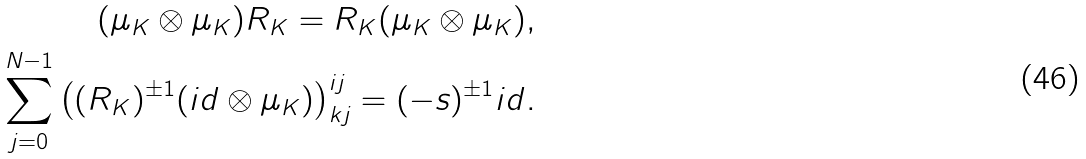<formula> <loc_0><loc_0><loc_500><loc_500>( \mu _ { K } \otimes \mu _ { K } ) { R } _ { K } = { R } _ { K } ( \mu _ { K } \otimes \mu _ { K } ) , \\ \sum _ { j = 0 } ^ { N - 1 } \left ( ( R _ { K } ) ^ { \pm 1 } ( i d \otimes \mu _ { K } ) \right ) _ { k j } ^ { i j } = ( - s ) ^ { \pm 1 } i d .</formula> 